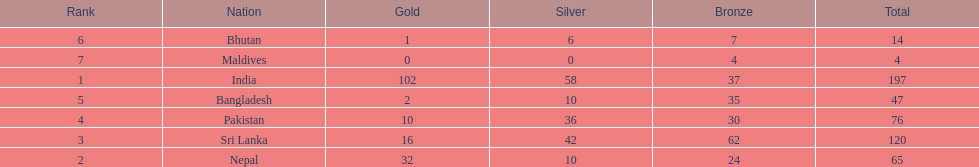How many more gold medals has nepal won than pakistan? 22. Parse the table in full. {'header': ['Rank', 'Nation', 'Gold', 'Silver', 'Bronze', 'Total'], 'rows': [['6', 'Bhutan', '1', '6', '7', '14'], ['7', 'Maldives', '0', '0', '4', '4'], ['1', 'India', '102', '58', '37', '197'], ['5', 'Bangladesh', '2', '10', '35', '47'], ['4', 'Pakistan', '10', '36', '30', '76'], ['3', 'Sri Lanka', '16', '42', '62', '120'], ['2', 'Nepal', '32', '10', '24', '65']]} 